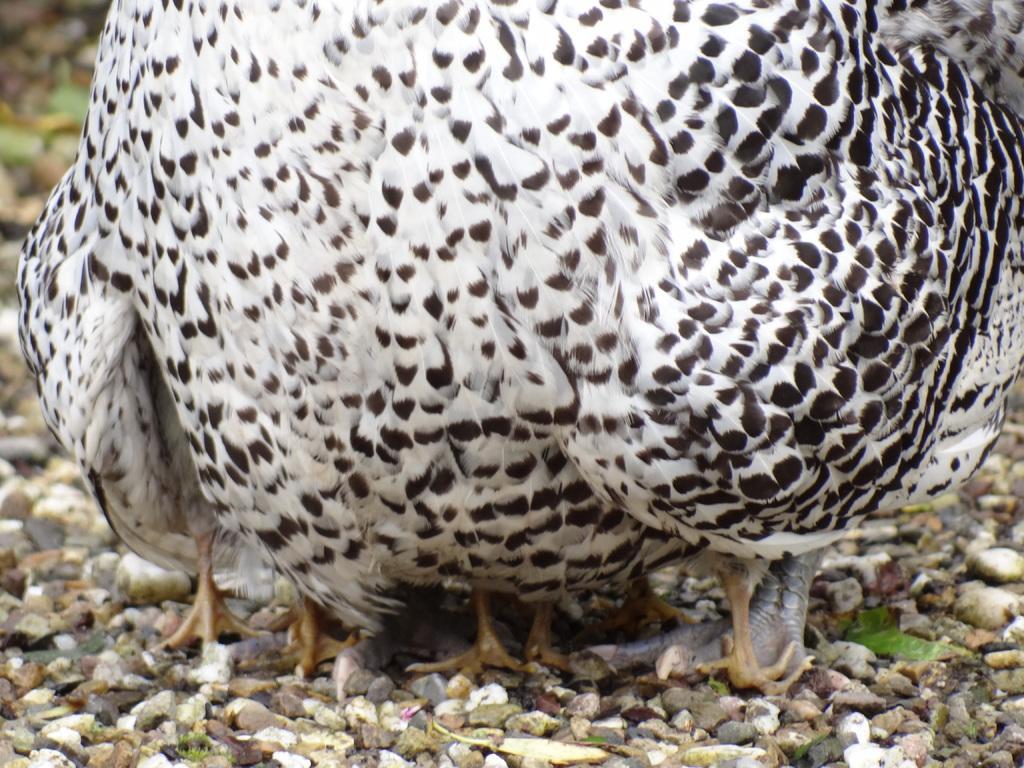Please provide a concise description of this image. In this picture we can see birds and some stones on the ground. 